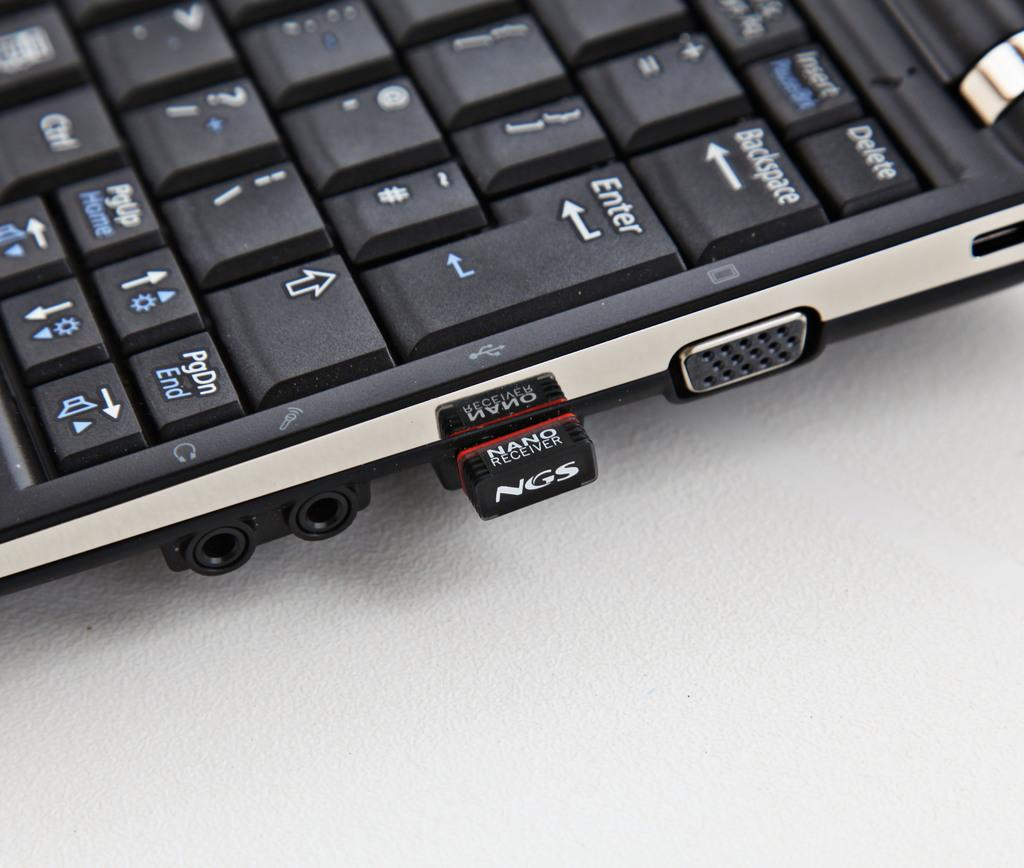<image>
Render a clear and concise summary of the photo. A "NGS Nano" flash drive hangs out of a laptop. 